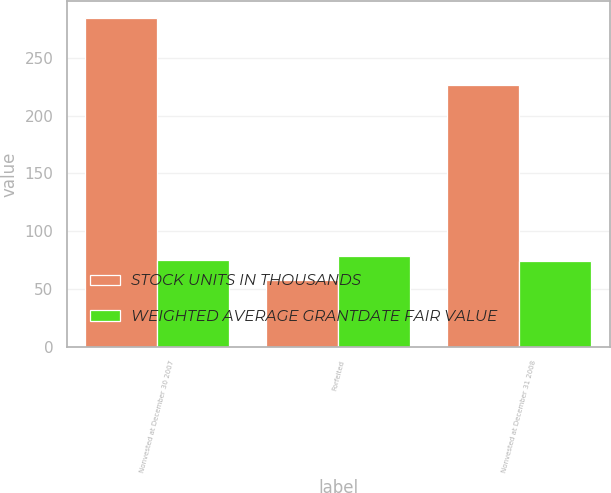Convert chart. <chart><loc_0><loc_0><loc_500><loc_500><stacked_bar_chart><ecel><fcel>Nonvested at December 30 2007<fcel>Forfeited<fcel>Nonvested at December 31 2008<nl><fcel>STOCK UNITS IN THOUSANDS<fcel>285<fcel>58<fcel>227<nl><fcel>WEIGHTED AVERAGE GRANTDATE FAIR VALUE<fcel>75.35<fcel>78.27<fcel>74.6<nl></chart> 